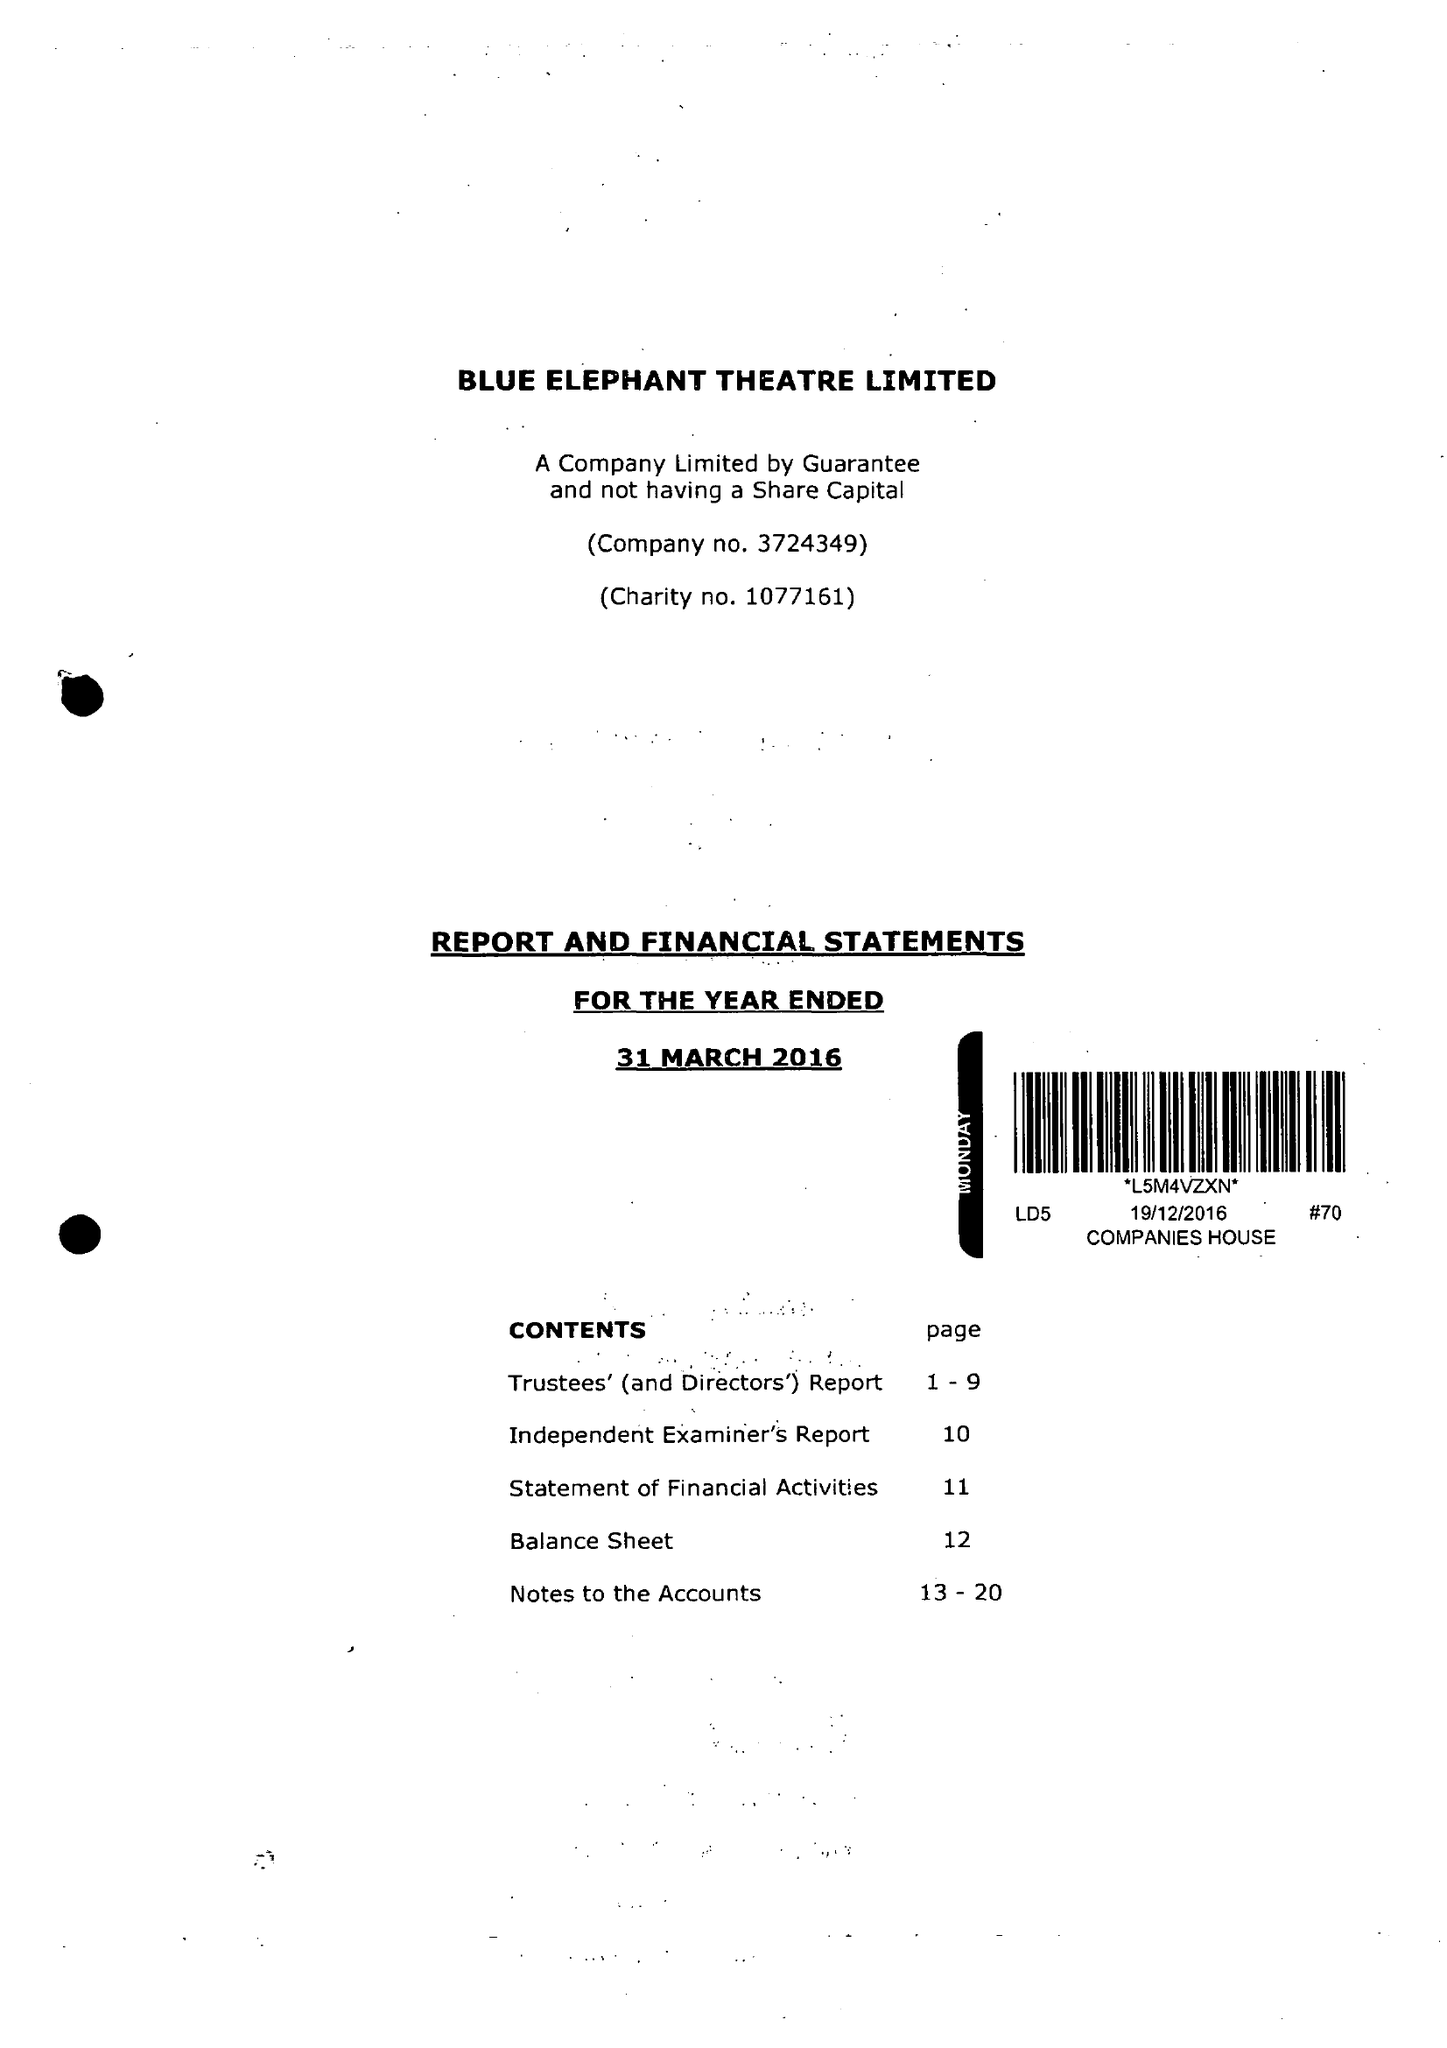What is the value for the charity_name?
Answer the question using a single word or phrase. Blue Elephant Theatre Ltd. 